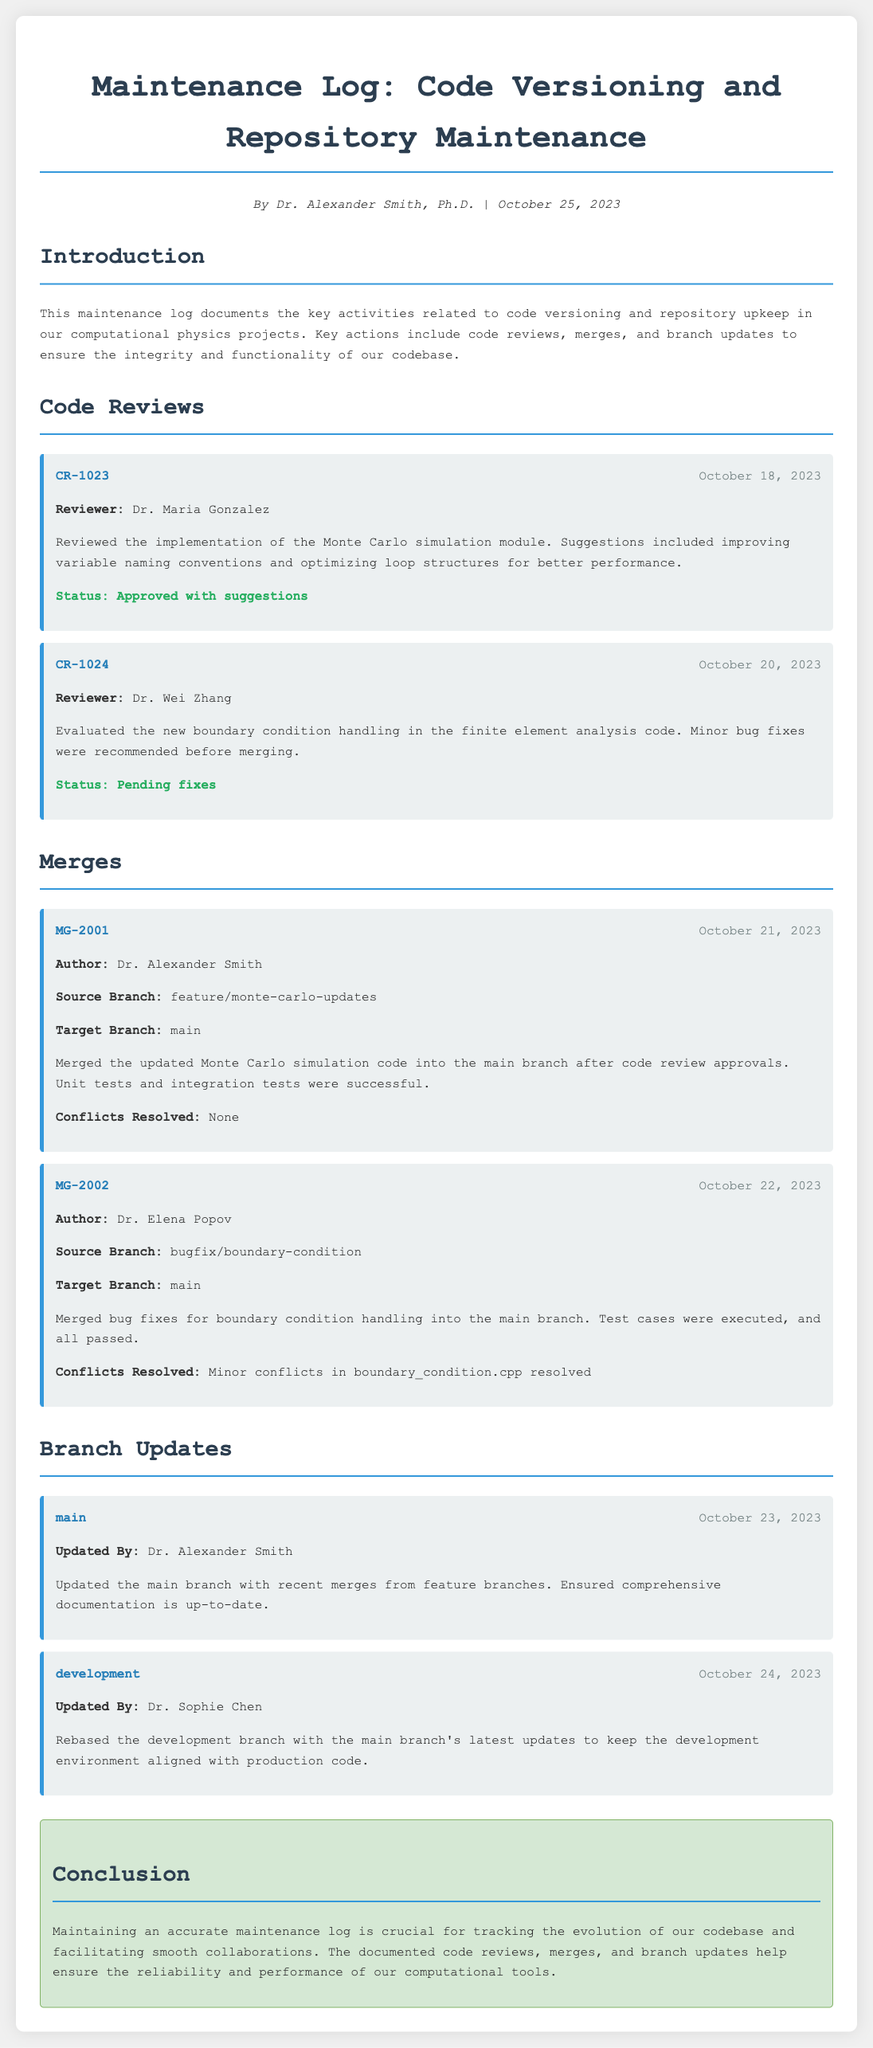What is the title of the document? The title is presented at the top section of the document, which is "Maintenance Log: Code Versioning and Repository Maintenance."
Answer: Maintenance Log: Code Versioning and Repository Maintenance Who reviewed the Monte Carlo simulation module? The entry specifies who conducted the review, which was Dr. Maria Gonzalez.
Answer: Dr. Maria Gonzalez What is the status of the boundary condition handling review? The document states that the review status indicates it is "Pending fixes."
Answer: Pending fixes What date did Dr. Alexander Smith merge the Monte Carlo simulation code? The entry records the merge date as October 21, 2023.
Answer: October 21, 2023 How many entries are documented under Code Reviews? By counting the entries listed under Code Reviews, there are two entries.
Answer: Two Which branch did Dr. Elena Popov update for boundary condition handling? The source branch for the merge is indicated as "bugfix/boundary-condition."
Answer: bugfix/boundary-condition When was the main branch last updated? The document records that the main branch was updated on October 23, 2023.
Answer: October 23, 2023 What modifications were made to the development branch? The summary mentions that the development branch was rebased with the main branch's updates.
Answer: Rebasing with main branch updates What was the conclusion about maintaining the log? The conclusion emphasizes the importance of having an accurate maintenance log for collaboration and reliability.
Answer: Crucial for tracking evolution and facilitating collaboration 